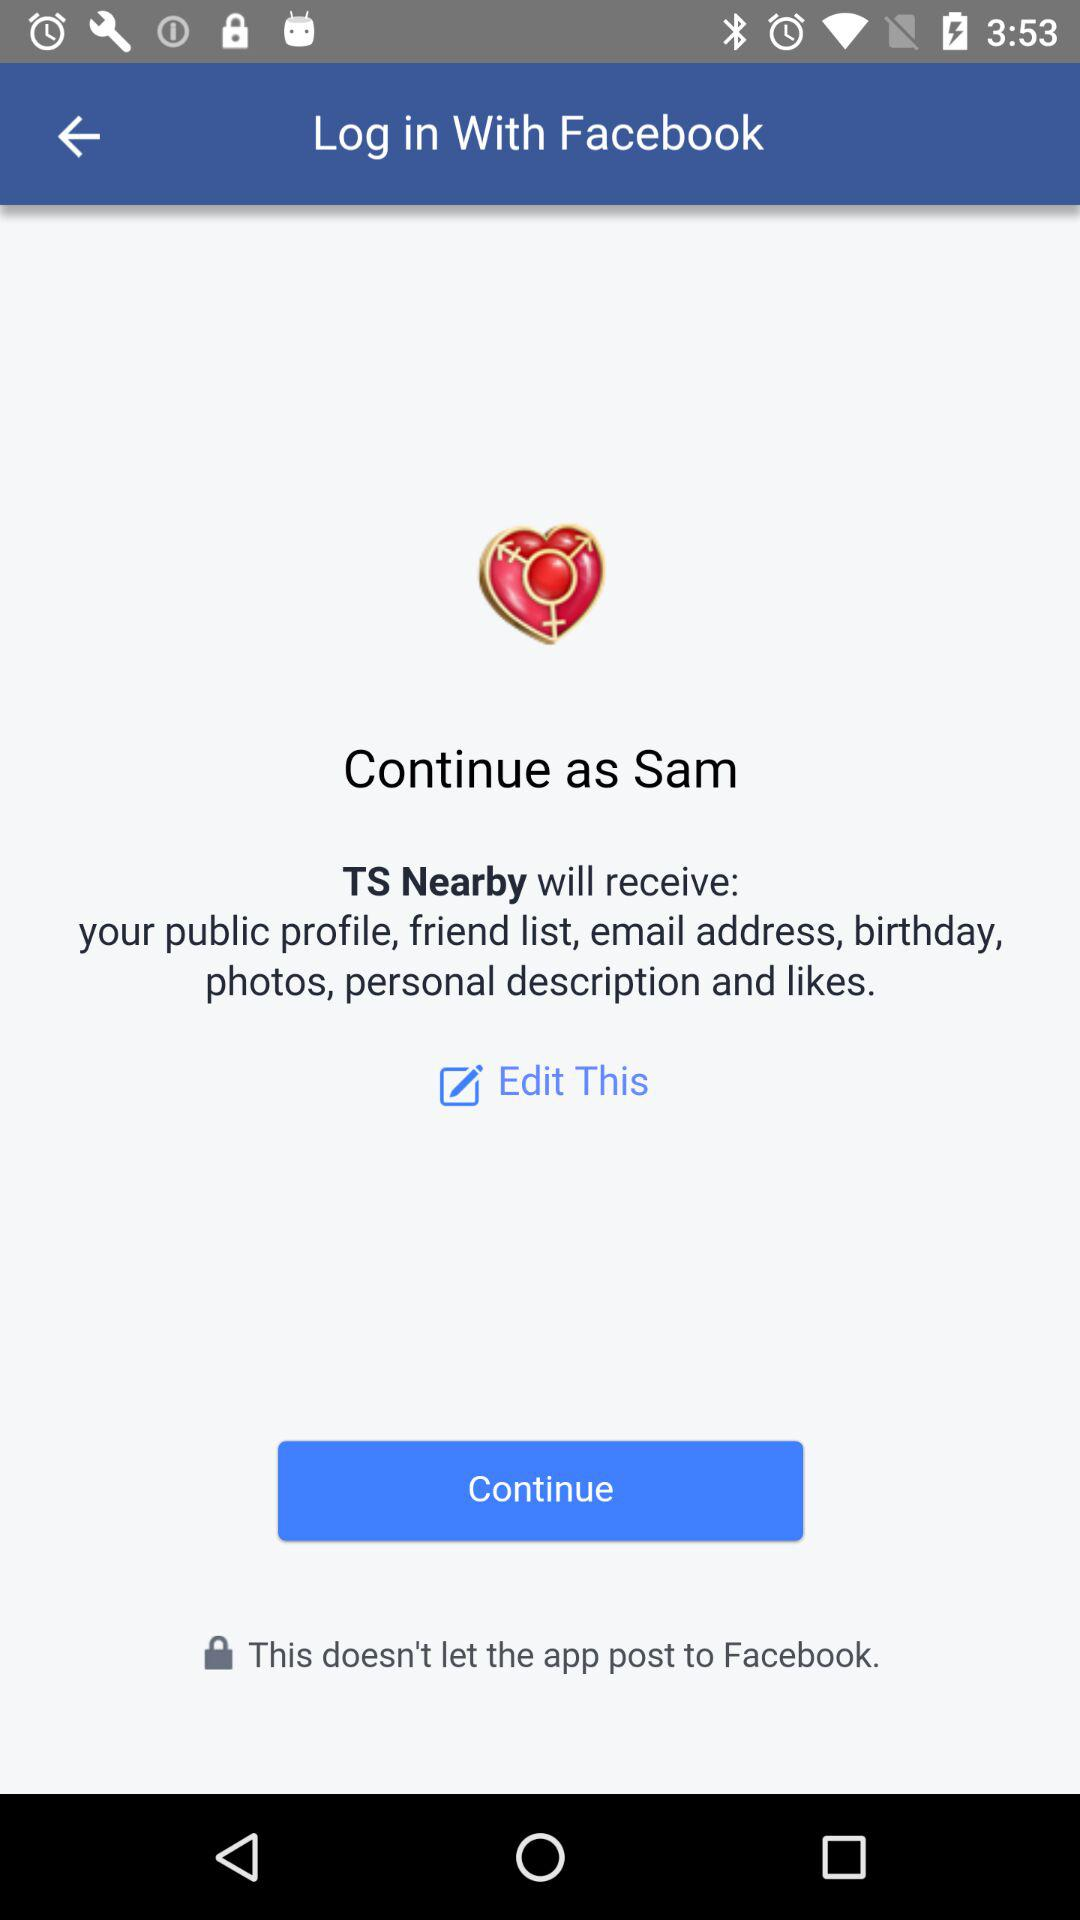What is the user name? The user name is Sam. 